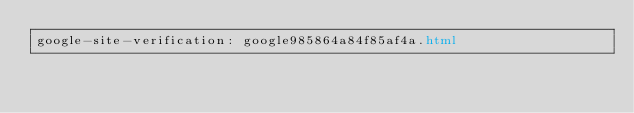Convert code to text. <code><loc_0><loc_0><loc_500><loc_500><_HTML_>google-site-verification: google985864a84f85af4a.html</code> 